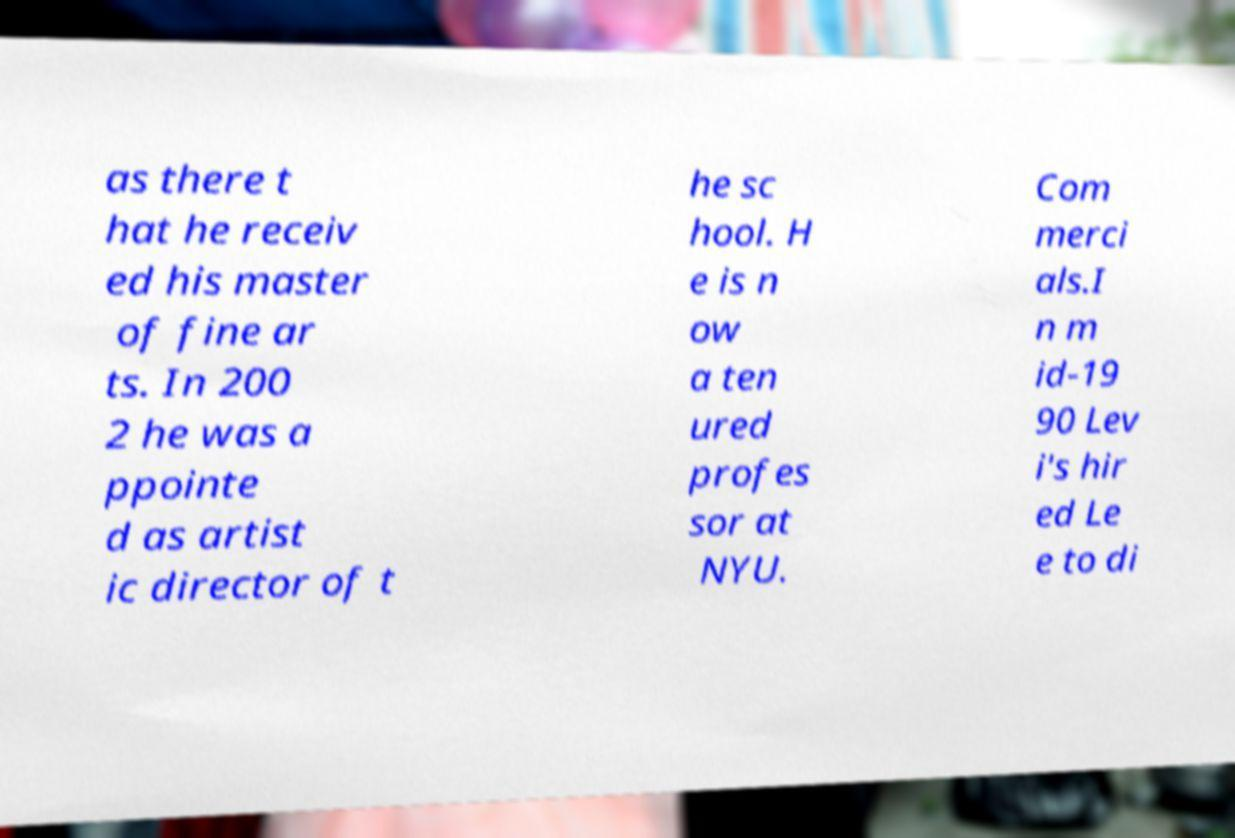What messages or text are displayed in this image? I need them in a readable, typed format. as there t hat he receiv ed his master of fine ar ts. In 200 2 he was a ppointe d as artist ic director of t he sc hool. H e is n ow a ten ured profes sor at NYU. Com merci als.I n m id-19 90 Lev i's hir ed Le e to di 